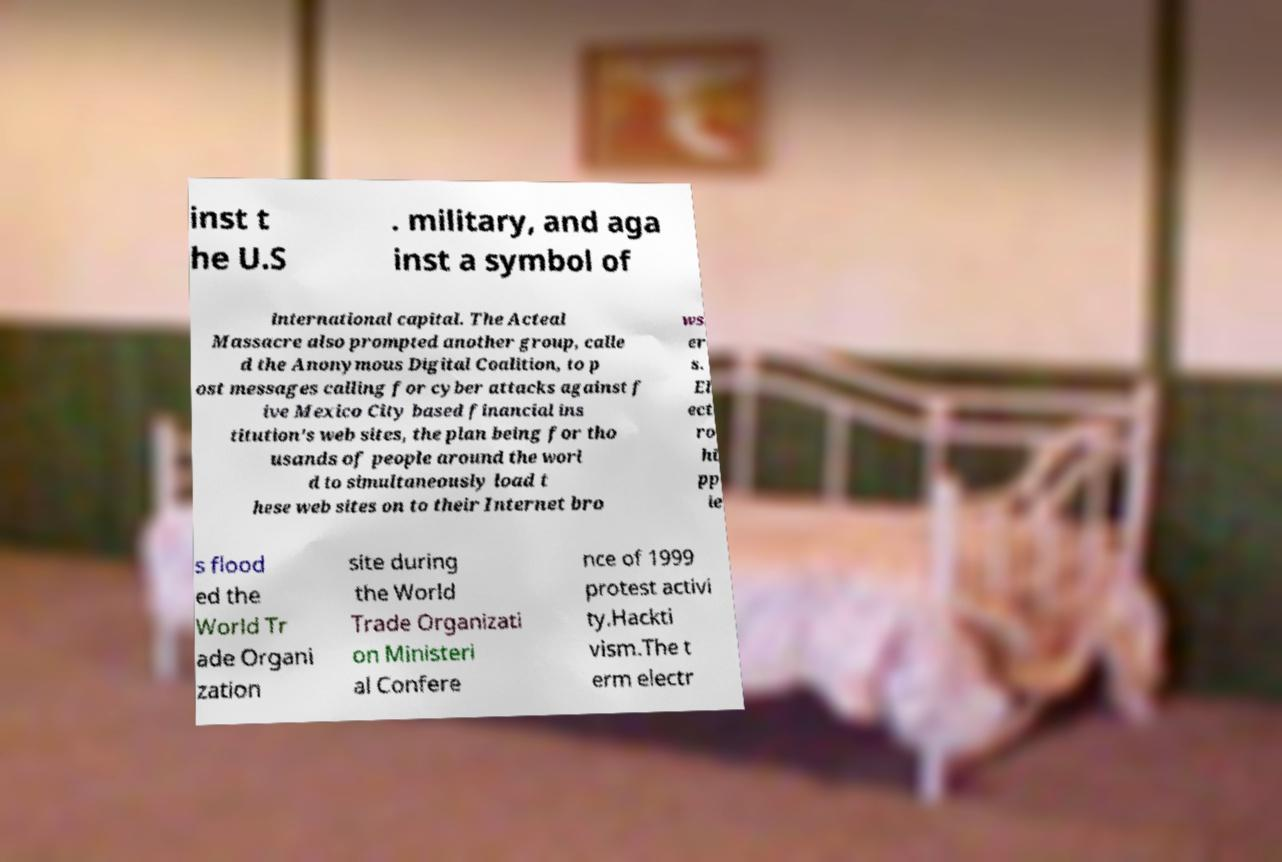Please identify and transcribe the text found in this image. inst t he U.S . military, and aga inst a symbol of international capital. The Acteal Massacre also prompted another group, calle d the Anonymous Digital Coalition, to p ost messages calling for cyber attacks against f ive Mexico City based financial ins titution’s web sites, the plan being for tho usands of people around the worl d to simultaneously load t hese web sites on to their Internet bro ws er s. El ect ro hi pp ie s flood ed the World Tr ade Organi zation site during the World Trade Organizati on Ministeri al Confere nce of 1999 protest activi ty.Hackti vism.The t erm electr 